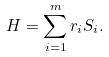<formula> <loc_0><loc_0><loc_500><loc_500>H = \sum _ { i = 1 } ^ { m } r _ { i } S _ { i } .</formula> 